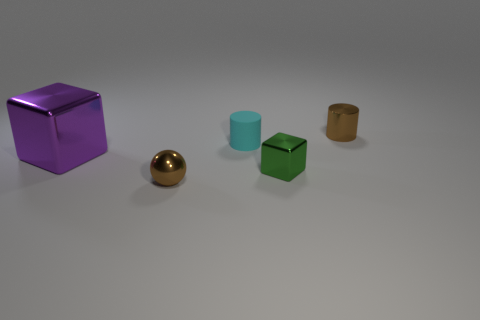What number of other objects are there of the same color as the tiny shiny cylinder?
Offer a very short reply. 1. Are there fewer brown spheres on the right side of the cyan thing than tiny cyan objects in front of the large metallic cube?
Give a very brief answer. No. There is a thing behind the cylinder left of the small brown shiny thing that is behind the big purple block; how big is it?
Give a very brief answer. Small. There is a thing that is both behind the big purple object and to the left of the small green metallic cube; what size is it?
Make the answer very short. Small. The small brown shiny thing on the left side of the brown thing that is behind the small metal sphere is what shape?
Keep it short and to the point. Sphere. Is there anything else of the same color as the shiny cylinder?
Your answer should be compact. Yes. There is a brown metal object that is in front of the green thing; what is its shape?
Provide a short and direct response. Sphere. There is a tiny thing that is both in front of the small cyan object and to the right of the matte object; what is its shape?
Your response must be concise. Cube. How many red objects are blocks or large blocks?
Keep it short and to the point. 0. There is a ball that is on the left side of the small green thing; is its color the same as the small rubber cylinder?
Keep it short and to the point. No. 